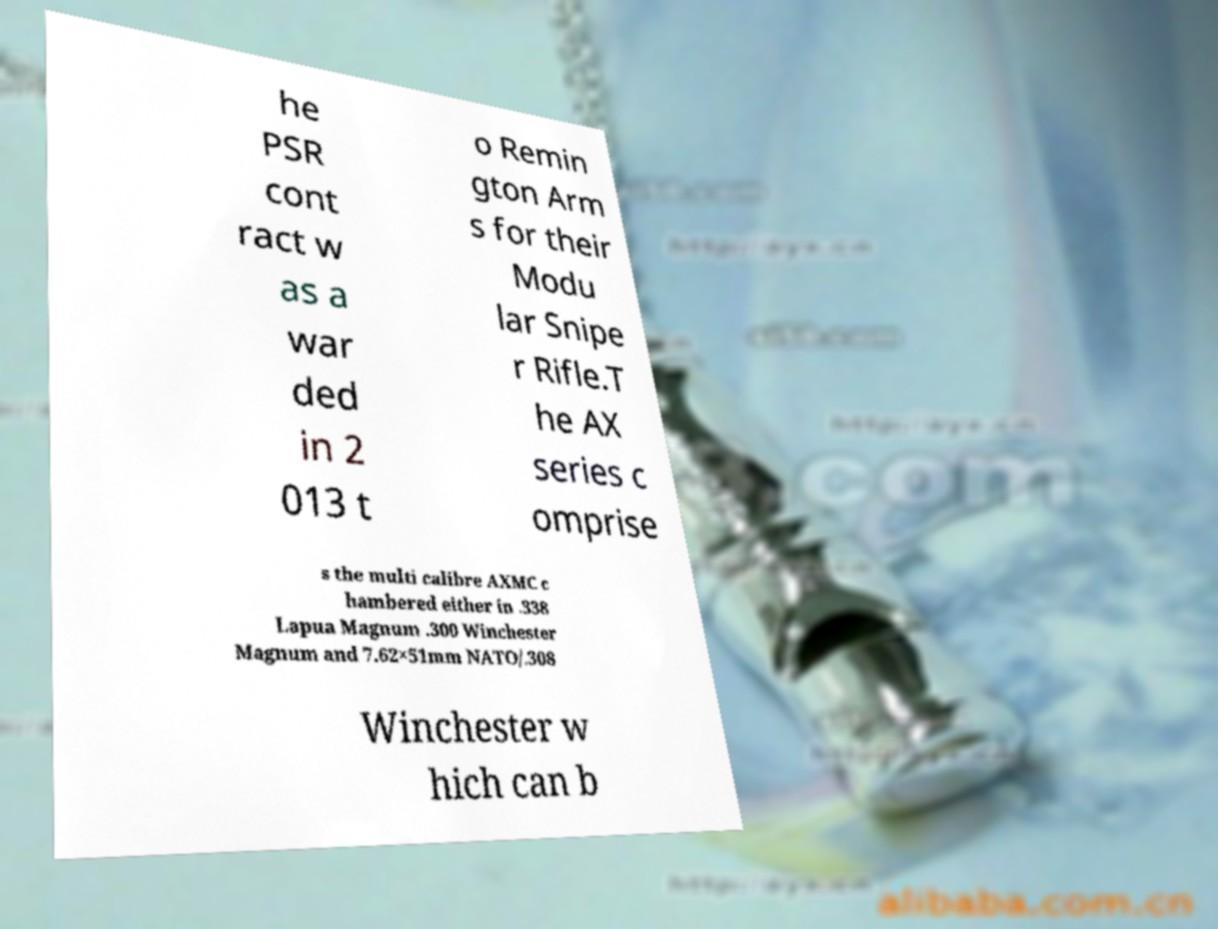For documentation purposes, I need the text within this image transcribed. Could you provide that? he PSR cont ract w as a war ded in 2 013 t o Remin gton Arm s for their Modu lar Snipe r Rifle.T he AX series c omprise s the multi calibre AXMC c hambered either in .338 Lapua Magnum .300 Winchester Magnum and 7.62×51mm NATO/.308 Winchester w hich can b 